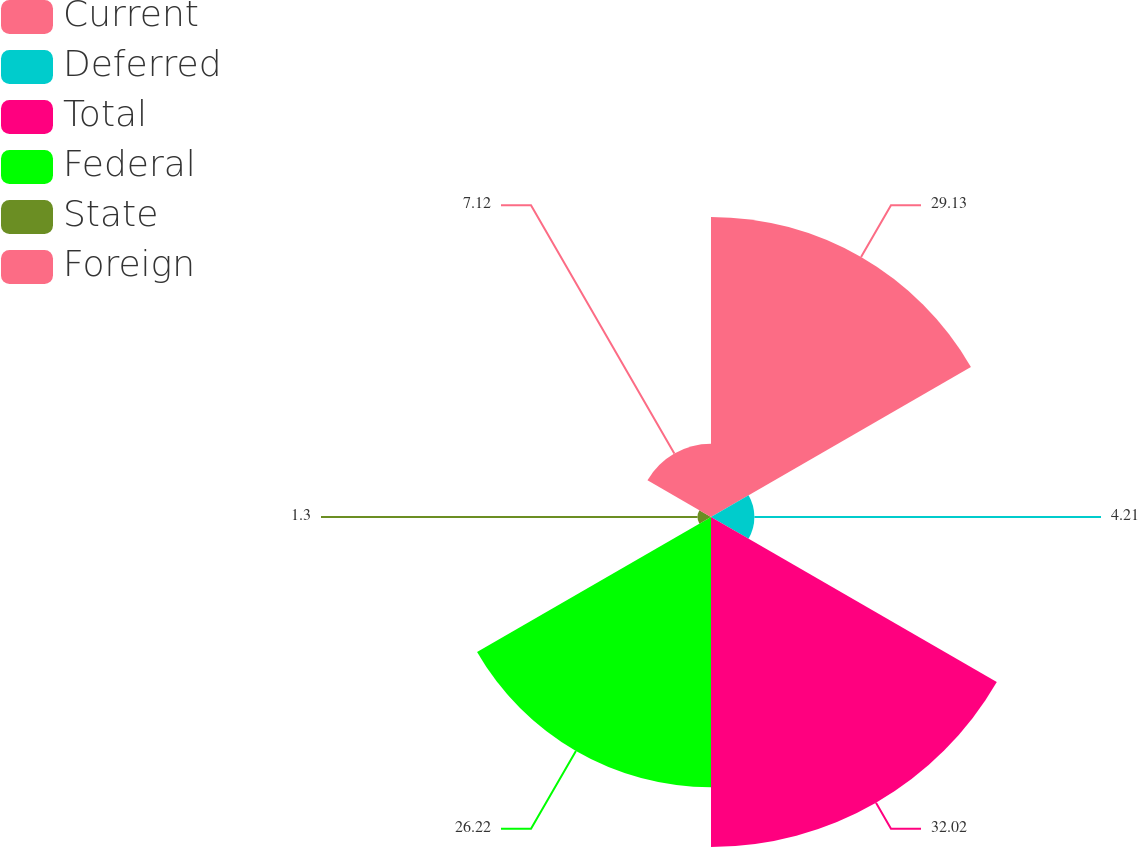Convert chart. <chart><loc_0><loc_0><loc_500><loc_500><pie_chart><fcel>Current<fcel>Deferred<fcel>Total<fcel>Federal<fcel>State<fcel>Foreign<nl><fcel>29.13%<fcel>4.21%<fcel>32.03%<fcel>26.22%<fcel>1.3%<fcel>7.12%<nl></chart> 